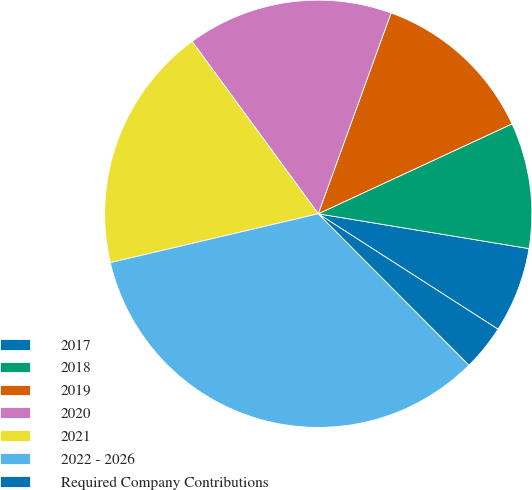<chart> <loc_0><loc_0><loc_500><loc_500><pie_chart><fcel>2017<fcel>2018<fcel>2019<fcel>2020<fcel>2021<fcel>2022 - 2026<fcel>Required Company Contributions<nl><fcel>6.48%<fcel>9.52%<fcel>12.55%<fcel>15.59%<fcel>18.62%<fcel>33.79%<fcel>3.45%<nl></chart> 